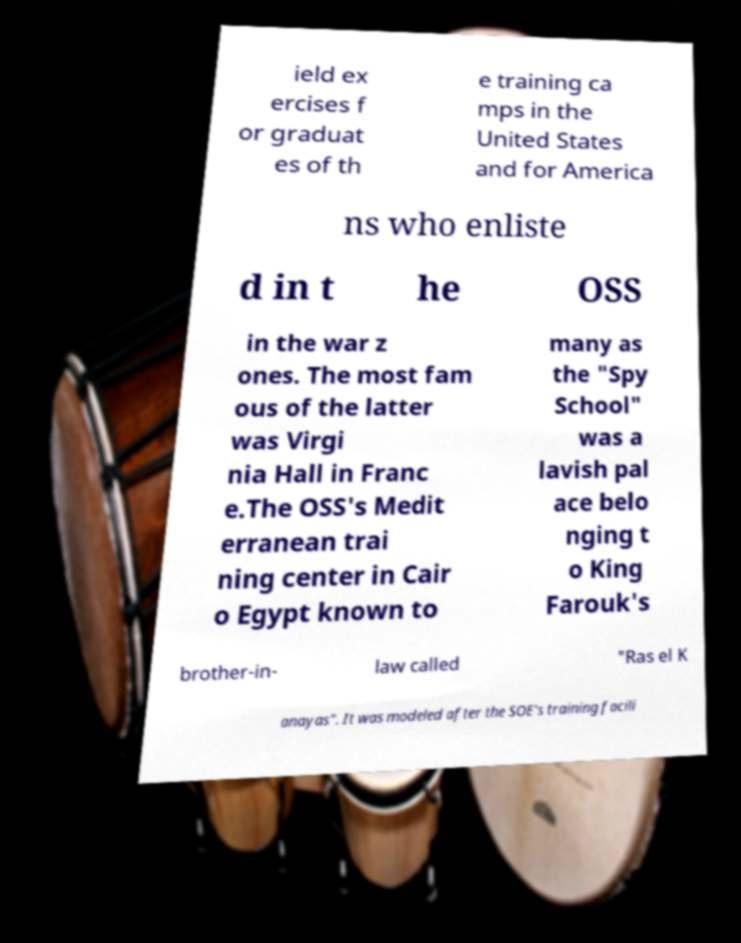Please identify and transcribe the text found in this image. ield ex ercises f or graduat es of th e training ca mps in the United States and for America ns who enliste d in t he OSS in the war z ones. The most fam ous of the latter was Virgi nia Hall in Franc e.The OSS's Medit erranean trai ning center in Cair o Egypt known to many as the "Spy School" was a lavish pal ace belo nging t o King Farouk's brother-in- law called "Ras el K anayas". It was modeled after the SOE's training facili 